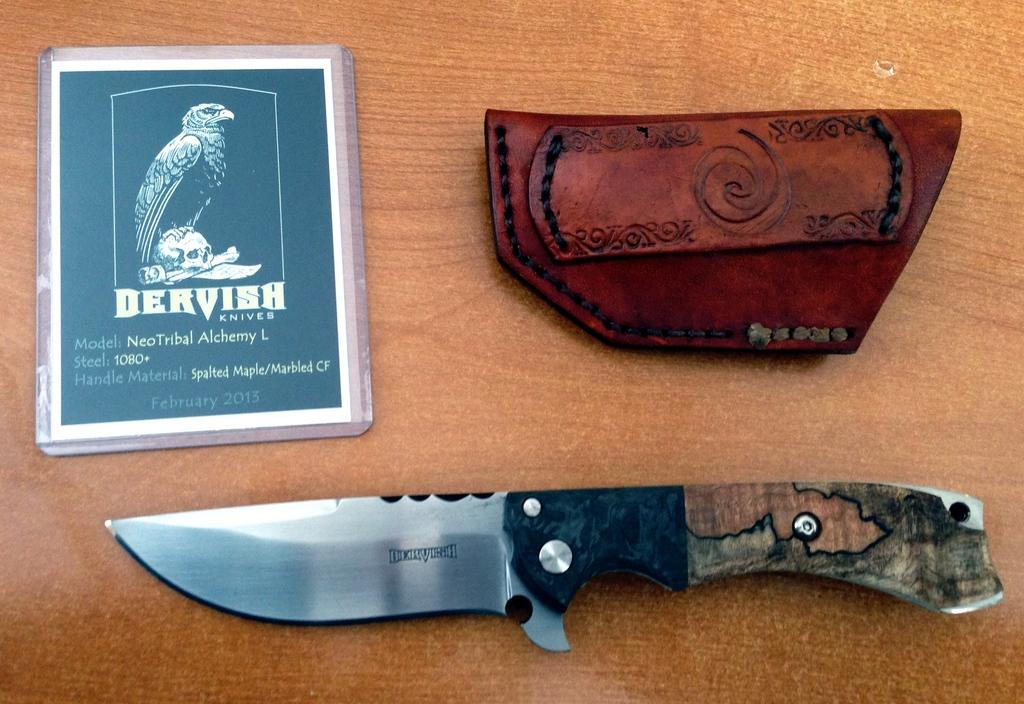What type of object can be seen in the image? There is a knife in the image. What else is present on the wooden surface? There is a leather pouch and a laminated card in the image. What material is the surface on which the objects are placed? The objects are on a wooden surface. What type of skirt is hanging on the wall in the image? There is no skirt present in the image; it only features a knife, leather pouch, and laminated card on a wooden surface. 